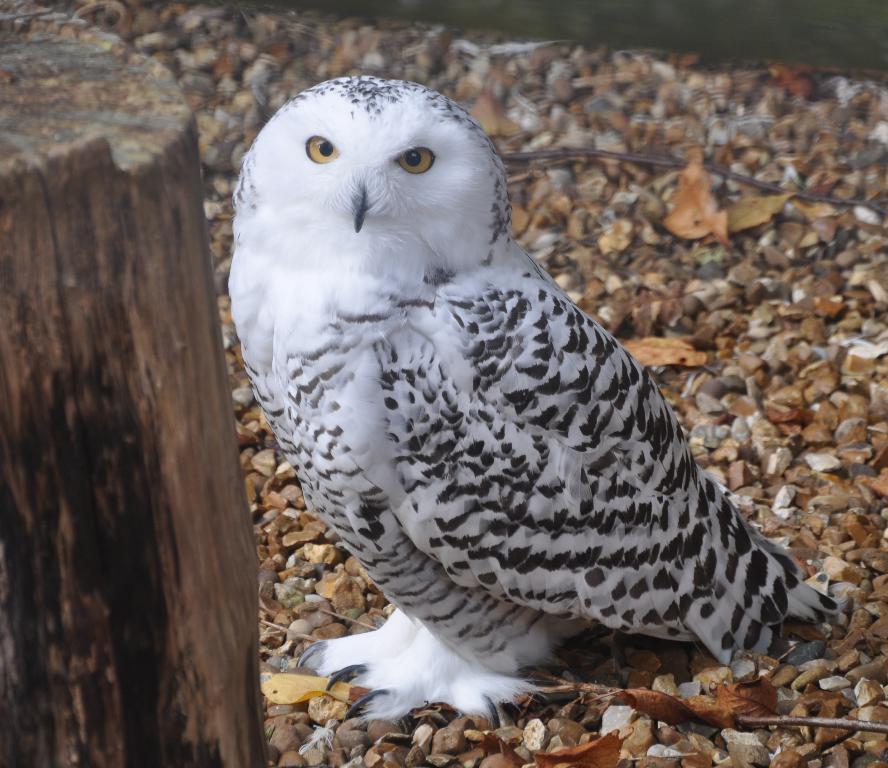Describe this image in one or two sentences. In the center of the image, we can see an owl and on the left, there is a trunk of the tree. 